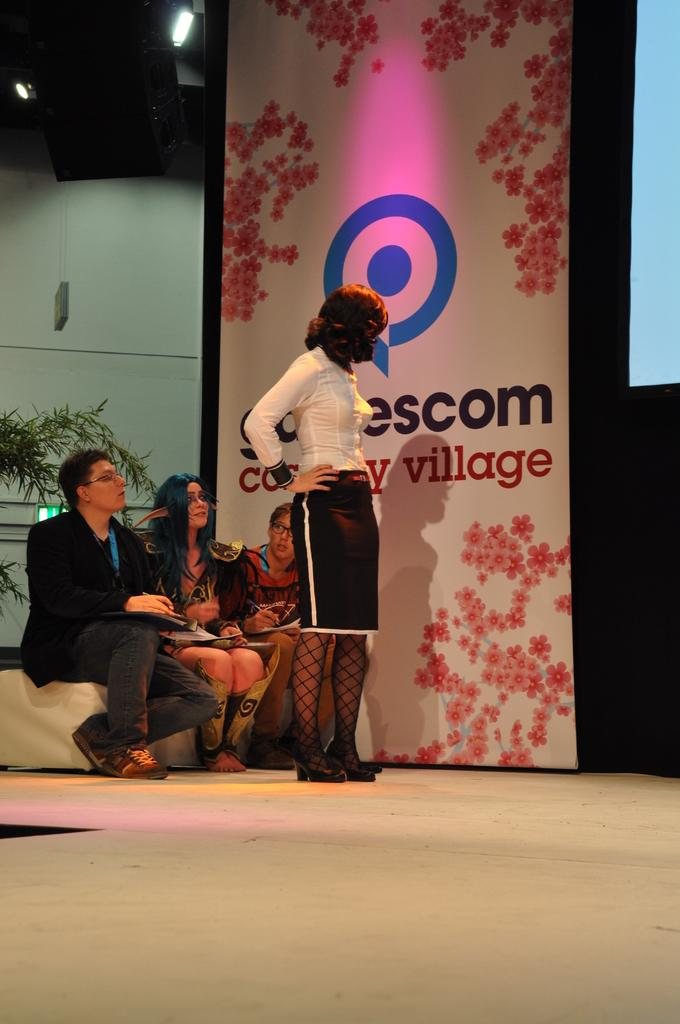What is the woman doing in the image? The woman is standing on a dais in the image. Where are the other persons located in the image? The persons are sitting on the left side of the image. What can be seen in the background of the image? There is a wall, a poster, and a screen in the background of the image. What type of pipe is the woman holding in the image? There is no pipe present in the image; the woman is standing on a dais without holding any object. 